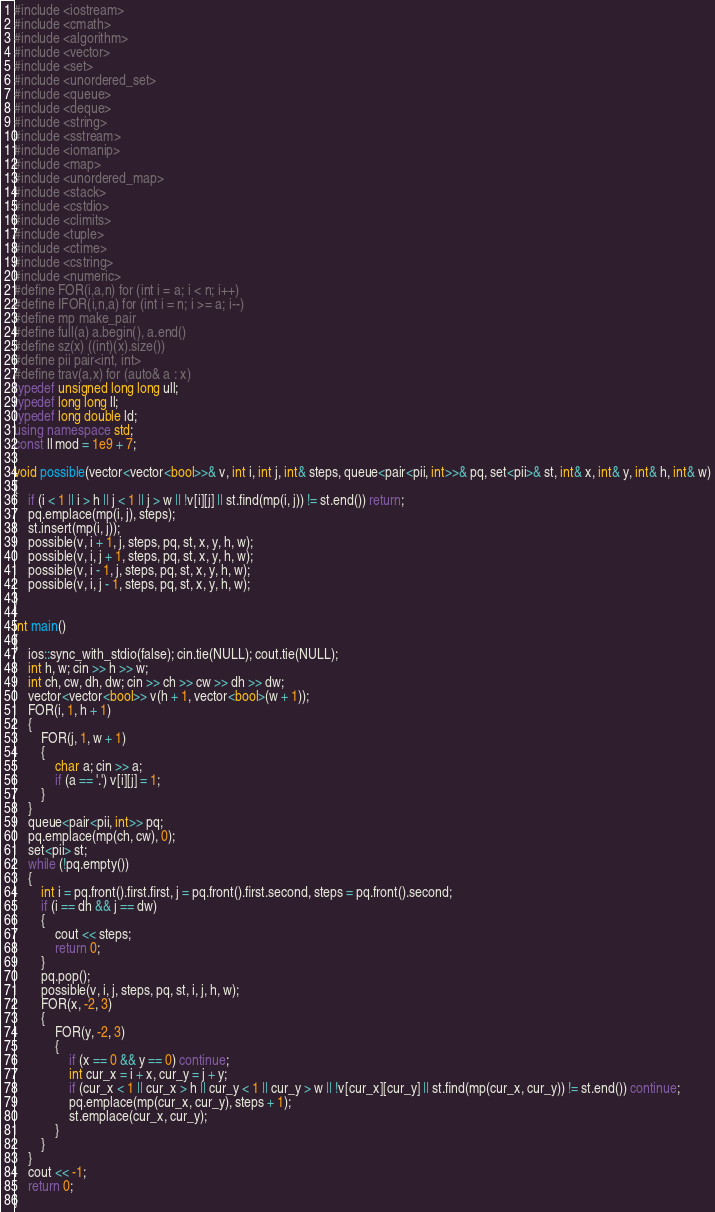<code> <loc_0><loc_0><loc_500><loc_500><_C++_>#include <iostream>
#include <cmath>
#include <algorithm>
#include <vector>
#include <set>
#include <unordered_set>
#include <queue>
#include <deque>
#include <string>
#include <sstream>
#include <iomanip>
#include <map>
#include <unordered_map>
#include <stack>
#include <cstdio>
#include <climits>
#include <tuple>
#include <ctime>
#include <cstring>
#include <numeric>
#define FOR(i,a,n) for (int i = a; i < n; i++)
#define IFOR(i,n,a) for (int i = n; i >= a; i--)
#define mp make_pair
#define full(a) a.begin(), a.end()
#define sz(x) ((int)(x).size())
#define pii pair<int, int>
#define trav(a,x) for (auto& a : x)
typedef unsigned long long ull;
typedef long long ll;
typedef long double ld;
using namespace std;
const ll mod = 1e9 + 7;

void possible(vector<vector<bool>>& v, int i, int j, int& steps, queue<pair<pii, int>>& pq, set<pii>& st, int& x, int& y, int& h, int& w)
{
    if (i < 1 || i > h || j < 1 || j > w || !v[i][j] || st.find(mp(i, j)) != st.end()) return;
    pq.emplace(mp(i, j), steps);
    st.insert(mp(i, j));
    possible(v, i + 1, j, steps, pq, st, x, y, h, w);
    possible(v, i, j + 1, steps, pq, st, x, y, h, w);
    possible(v, i - 1, j, steps, pq, st, x, y, h, w);
    possible(v, i, j - 1, steps, pq, st, x, y, h, w);
}

int main()
{
    ios::sync_with_stdio(false); cin.tie(NULL); cout.tie(NULL);
    int h, w; cin >> h >> w;
    int ch, cw, dh, dw; cin >> ch >> cw >> dh >> dw;
    vector<vector<bool>> v(h + 1, vector<bool>(w + 1));
    FOR(i, 1, h + 1)
    {
        FOR(j, 1, w + 1)
        {
            char a; cin >> a;
            if (a == '.') v[i][j] = 1;
        }
    }
    queue<pair<pii, int>> pq;
    pq.emplace(mp(ch, cw), 0);
    set<pii> st;
    while (!pq.empty())
    {
        int i = pq.front().first.first, j = pq.front().first.second, steps = pq.front().second;
        if (i == dh && j == dw)
        {
            cout << steps;
            return 0;
        }
        pq.pop();
        possible(v, i, j, steps, pq, st, i, j, h, w);
        FOR(x, -2, 3)
        {
            FOR(y, -2, 3)
            {
                if (x == 0 && y == 0) continue;
                int cur_x = i + x, cur_y = j + y;
                if (cur_x < 1 || cur_x > h || cur_y < 1 || cur_y > w || !v[cur_x][cur_y] || st.find(mp(cur_x, cur_y)) != st.end()) continue;
                pq.emplace(mp(cur_x, cur_y), steps + 1);
                st.emplace(cur_x, cur_y);
            }
        }
    }
    cout << -1;
    return 0;
}
</code> 